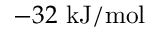<formula> <loc_0><loc_0><loc_500><loc_500>- 3 2 \ k J / m o l</formula> 